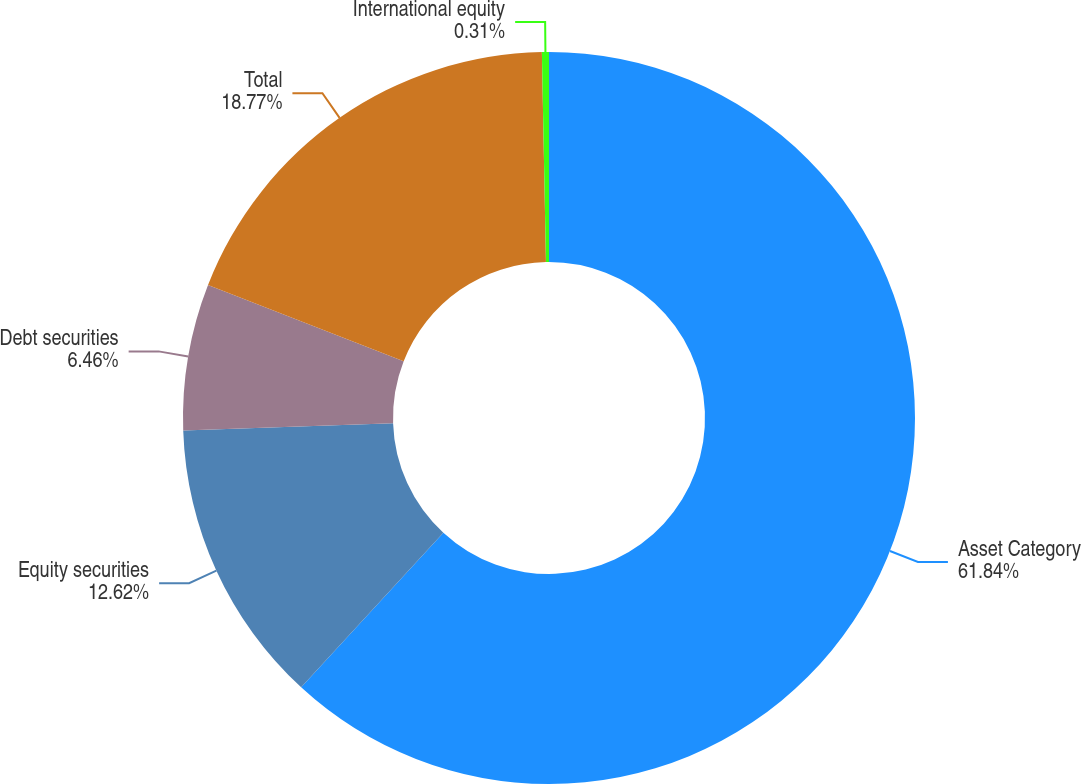<chart> <loc_0><loc_0><loc_500><loc_500><pie_chart><fcel>Asset Category<fcel>Equity securities<fcel>Debt securities<fcel>Total<fcel>International equity<nl><fcel>61.84%<fcel>12.62%<fcel>6.46%<fcel>18.77%<fcel>0.31%<nl></chart> 